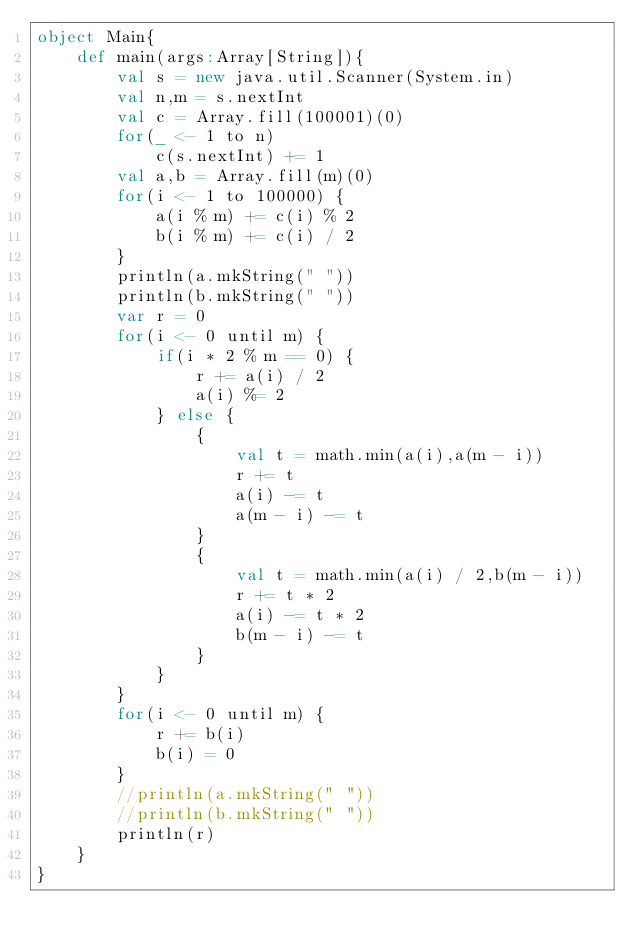Convert code to text. <code><loc_0><loc_0><loc_500><loc_500><_Scala_>object Main{
	def main(args:Array[String]){
		val s = new java.util.Scanner(System.in)
		val n,m = s.nextInt
		val c = Array.fill(100001)(0)
		for(_ <- 1 to n)
			c(s.nextInt) += 1
		val a,b = Array.fill(m)(0)
		for(i <- 1 to 100000) {
			a(i % m) += c(i) % 2
			b(i % m) += c(i) / 2
		}
		println(a.mkString(" "))
		println(b.mkString(" "))
		var r = 0
		for(i <- 0 until m) {
			if(i * 2 % m == 0) {
				r += a(i) / 2
				a(i) %= 2
			} else {
				{
					val t = math.min(a(i),a(m - i))
					r += t
					a(i) -= t
					a(m - i) -= t
				}
				{
					val t = math.min(a(i) / 2,b(m - i))
					r += t * 2
					a(i) -= t * 2
					b(m - i) -= t
				}
			}
		}
		for(i <- 0 until m) {
			r += b(i)
			b(i) = 0
		}
		//println(a.mkString(" "))
		//println(b.mkString(" "))
		println(r)
	}
}
</code> 